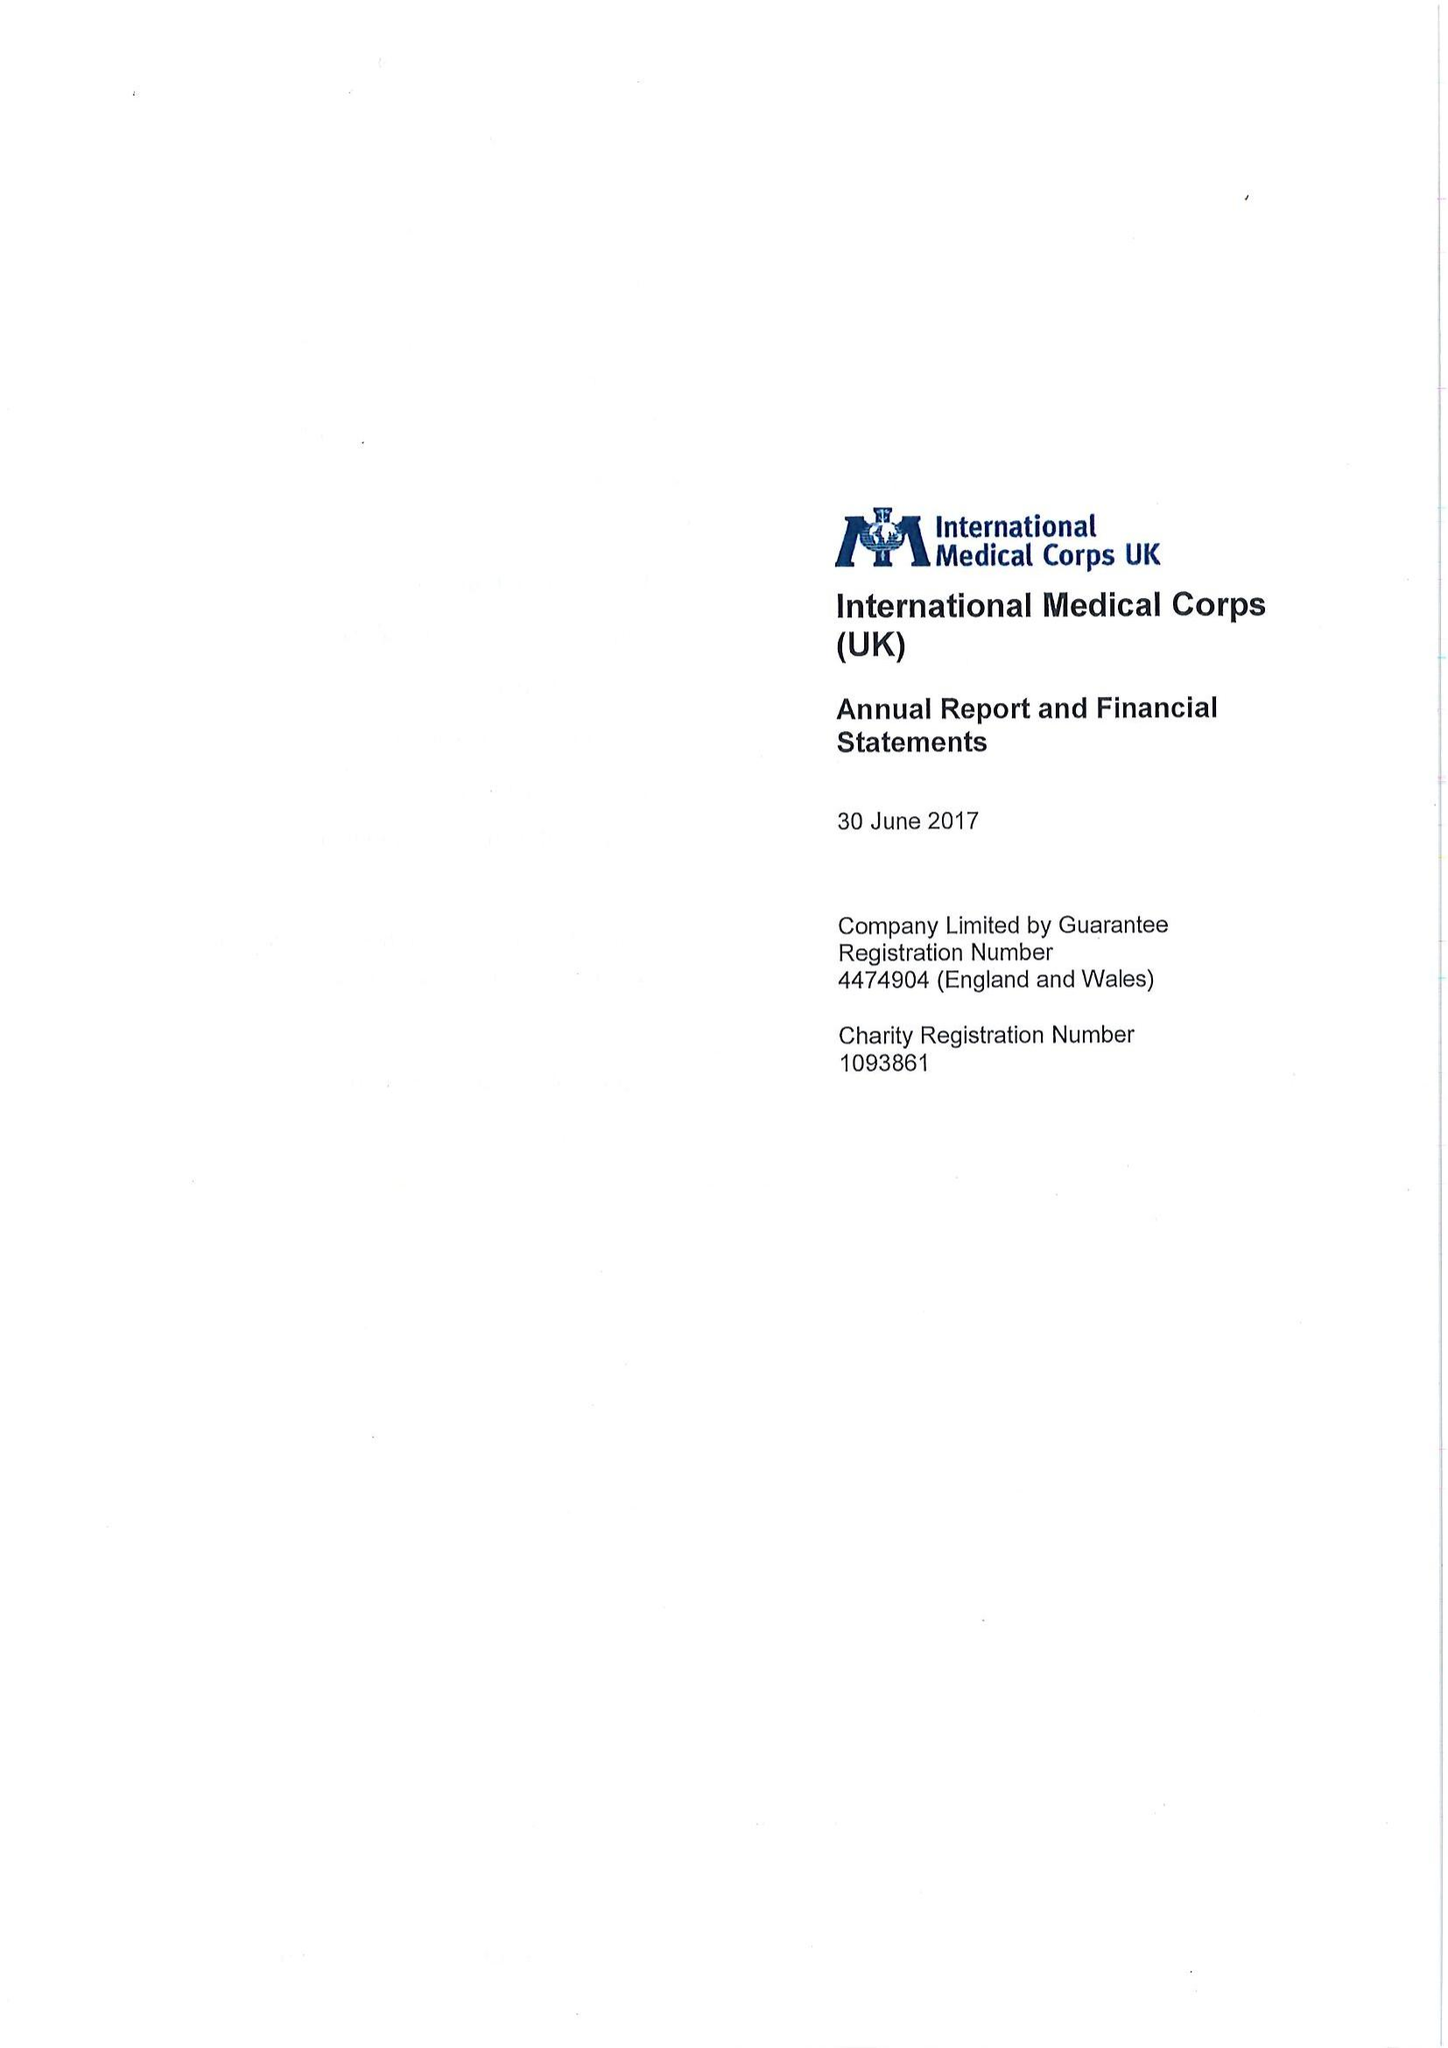What is the value for the income_annually_in_british_pounds?
Answer the question using a single word or phrase. 123658942.00 